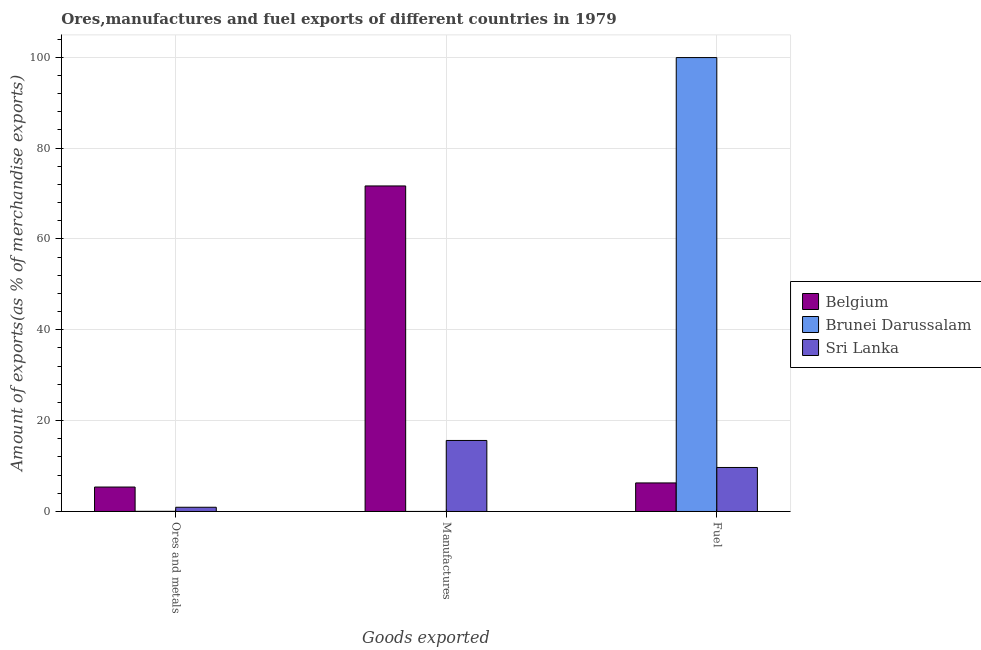How many groups of bars are there?
Offer a terse response. 3. Are the number of bars per tick equal to the number of legend labels?
Provide a succinct answer. Yes. How many bars are there on the 3rd tick from the right?
Your response must be concise. 3. What is the label of the 1st group of bars from the left?
Ensure brevity in your answer.  Ores and metals. What is the percentage of ores and metals exports in Sri Lanka?
Give a very brief answer. 0.93. Across all countries, what is the maximum percentage of fuel exports?
Keep it short and to the point. 99.93. Across all countries, what is the minimum percentage of manufactures exports?
Keep it short and to the point. 0.01. In which country was the percentage of manufactures exports maximum?
Give a very brief answer. Belgium. In which country was the percentage of fuel exports minimum?
Ensure brevity in your answer.  Belgium. What is the total percentage of manufactures exports in the graph?
Ensure brevity in your answer.  87.31. What is the difference between the percentage of ores and metals exports in Sri Lanka and that in Belgium?
Your response must be concise. -4.45. What is the difference between the percentage of ores and metals exports in Brunei Darussalam and the percentage of manufactures exports in Belgium?
Your response must be concise. -71.63. What is the average percentage of fuel exports per country?
Provide a short and direct response. 38.64. What is the difference between the percentage of fuel exports and percentage of ores and metals exports in Brunei Darussalam?
Your response must be concise. 99.9. What is the ratio of the percentage of manufactures exports in Belgium to that in Brunei Darussalam?
Offer a very short reply. 1.02e+04. Is the difference between the percentage of manufactures exports in Brunei Darussalam and Belgium greater than the difference between the percentage of ores and metals exports in Brunei Darussalam and Belgium?
Provide a short and direct response. No. What is the difference between the highest and the second highest percentage of manufactures exports?
Offer a terse response. 56.03. What is the difference between the highest and the lowest percentage of manufactures exports?
Your response must be concise. 71.66. Is the sum of the percentage of fuel exports in Brunei Darussalam and Belgium greater than the maximum percentage of manufactures exports across all countries?
Your answer should be compact. Yes. What does the 2nd bar from the left in Fuel represents?
Your response must be concise. Brunei Darussalam. What does the 2nd bar from the right in Ores and metals represents?
Your answer should be very brief. Brunei Darussalam. What is the difference between two consecutive major ticks on the Y-axis?
Offer a very short reply. 20. Are the values on the major ticks of Y-axis written in scientific E-notation?
Your answer should be very brief. No. Does the graph contain grids?
Keep it short and to the point. Yes. Where does the legend appear in the graph?
Make the answer very short. Center right. How many legend labels are there?
Offer a very short reply. 3. What is the title of the graph?
Offer a terse response. Ores,manufactures and fuel exports of different countries in 1979. Does "Afghanistan" appear as one of the legend labels in the graph?
Provide a short and direct response. No. What is the label or title of the X-axis?
Offer a very short reply. Goods exported. What is the label or title of the Y-axis?
Make the answer very short. Amount of exports(as % of merchandise exports). What is the Amount of exports(as % of merchandise exports) in Belgium in Ores and metals?
Offer a very short reply. 5.38. What is the Amount of exports(as % of merchandise exports) in Brunei Darussalam in Ores and metals?
Give a very brief answer. 0.03. What is the Amount of exports(as % of merchandise exports) in Sri Lanka in Ores and metals?
Your answer should be compact. 0.93. What is the Amount of exports(as % of merchandise exports) in Belgium in Manufactures?
Keep it short and to the point. 71.67. What is the Amount of exports(as % of merchandise exports) in Brunei Darussalam in Manufactures?
Provide a short and direct response. 0.01. What is the Amount of exports(as % of merchandise exports) in Sri Lanka in Manufactures?
Your answer should be compact. 15.64. What is the Amount of exports(as % of merchandise exports) of Belgium in Fuel?
Provide a succinct answer. 6.29. What is the Amount of exports(as % of merchandise exports) in Brunei Darussalam in Fuel?
Your response must be concise. 99.93. What is the Amount of exports(as % of merchandise exports) in Sri Lanka in Fuel?
Provide a short and direct response. 9.69. Across all Goods exported, what is the maximum Amount of exports(as % of merchandise exports) of Belgium?
Ensure brevity in your answer.  71.67. Across all Goods exported, what is the maximum Amount of exports(as % of merchandise exports) of Brunei Darussalam?
Provide a short and direct response. 99.93. Across all Goods exported, what is the maximum Amount of exports(as % of merchandise exports) in Sri Lanka?
Offer a terse response. 15.64. Across all Goods exported, what is the minimum Amount of exports(as % of merchandise exports) of Belgium?
Offer a very short reply. 5.38. Across all Goods exported, what is the minimum Amount of exports(as % of merchandise exports) in Brunei Darussalam?
Provide a short and direct response. 0.01. Across all Goods exported, what is the minimum Amount of exports(as % of merchandise exports) of Sri Lanka?
Your answer should be very brief. 0.93. What is the total Amount of exports(as % of merchandise exports) in Belgium in the graph?
Provide a succinct answer. 83.34. What is the total Amount of exports(as % of merchandise exports) in Brunei Darussalam in the graph?
Provide a short and direct response. 99.97. What is the total Amount of exports(as % of merchandise exports) of Sri Lanka in the graph?
Provide a short and direct response. 26.25. What is the difference between the Amount of exports(as % of merchandise exports) of Belgium in Ores and metals and that in Manufactures?
Your answer should be compact. -66.29. What is the difference between the Amount of exports(as % of merchandise exports) of Brunei Darussalam in Ores and metals and that in Manufactures?
Ensure brevity in your answer.  0.03. What is the difference between the Amount of exports(as % of merchandise exports) of Sri Lanka in Ores and metals and that in Manufactures?
Offer a very short reply. -14.71. What is the difference between the Amount of exports(as % of merchandise exports) in Belgium in Ores and metals and that in Fuel?
Provide a succinct answer. -0.91. What is the difference between the Amount of exports(as % of merchandise exports) in Brunei Darussalam in Ores and metals and that in Fuel?
Your answer should be very brief. -99.9. What is the difference between the Amount of exports(as % of merchandise exports) in Sri Lanka in Ores and metals and that in Fuel?
Your response must be concise. -8.76. What is the difference between the Amount of exports(as % of merchandise exports) in Belgium in Manufactures and that in Fuel?
Ensure brevity in your answer.  65.38. What is the difference between the Amount of exports(as % of merchandise exports) in Brunei Darussalam in Manufactures and that in Fuel?
Your answer should be compact. -99.92. What is the difference between the Amount of exports(as % of merchandise exports) of Sri Lanka in Manufactures and that in Fuel?
Give a very brief answer. 5.95. What is the difference between the Amount of exports(as % of merchandise exports) in Belgium in Ores and metals and the Amount of exports(as % of merchandise exports) in Brunei Darussalam in Manufactures?
Offer a very short reply. 5.37. What is the difference between the Amount of exports(as % of merchandise exports) of Belgium in Ores and metals and the Amount of exports(as % of merchandise exports) of Sri Lanka in Manufactures?
Make the answer very short. -10.26. What is the difference between the Amount of exports(as % of merchandise exports) of Brunei Darussalam in Ores and metals and the Amount of exports(as % of merchandise exports) of Sri Lanka in Manufactures?
Offer a very short reply. -15.6. What is the difference between the Amount of exports(as % of merchandise exports) of Belgium in Ores and metals and the Amount of exports(as % of merchandise exports) of Brunei Darussalam in Fuel?
Provide a succinct answer. -94.55. What is the difference between the Amount of exports(as % of merchandise exports) in Belgium in Ores and metals and the Amount of exports(as % of merchandise exports) in Sri Lanka in Fuel?
Ensure brevity in your answer.  -4.31. What is the difference between the Amount of exports(as % of merchandise exports) in Brunei Darussalam in Ores and metals and the Amount of exports(as % of merchandise exports) in Sri Lanka in Fuel?
Provide a short and direct response. -9.65. What is the difference between the Amount of exports(as % of merchandise exports) of Belgium in Manufactures and the Amount of exports(as % of merchandise exports) of Brunei Darussalam in Fuel?
Ensure brevity in your answer.  -28.26. What is the difference between the Amount of exports(as % of merchandise exports) in Belgium in Manufactures and the Amount of exports(as % of merchandise exports) in Sri Lanka in Fuel?
Give a very brief answer. 61.98. What is the difference between the Amount of exports(as % of merchandise exports) in Brunei Darussalam in Manufactures and the Amount of exports(as % of merchandise exports) in Sri Lanka in Fuel?
Provide a short and direct response. -9.68. What is the average Amount of exports(as % of merchandise exports) in Belgium per Goods exported?
Your response must be concise. 27.78. What is the average Amount of exports(as % of merchandise exports) in Brunei Darussalam per Goods exported?
Provide a succinct answer. 33.32. What is the average Amount of exports(as % of merchandise exports) of Sri Lanka per Goods exported?
Give a very brief answer. 8.75. What is the difference between the Amount of exports(as % of merchandise exports) of Belgium and Amount of exports(as % of merchandise exports) of Brunei Darussalam in Ores and metals?
Your answer should be compact. 5.34. What is the difference between the Amount of exports(as % of merchandise exports) in Belgium and Amount of exports(as % of merchandise exports) in Sri Lanka in Ores and metals?
Provide a short and direct response. 4.45. What is the difference between the Amount of exports(as % of merchandise exports) of Brunei Darussalam and Amount of exports(as % of merchandise exports) of Sri Lanka in Ores and metals?
Your answer should be compact. -0.89. What is the difference between the Amount of exports(as % of merchandise exports) in Belgium and Amount of exports(as % of merchandise exports) in Brunei Darussalam in Manufactures?
Provide a succinct answer. 71.66. What is the difference between the Amount of exports(as % of merchandise exports) in Belgium and Amount of exports(as % of merchandise exports) in Sri Lanka in Manufactures?
Keep it short and to the point. 56.03. What is the difference between the Amount of exports(as % of merchandise exports) of Brunei Darussalam and Amount of exports(as % of merchandise exports) of Sri Lanka in Manufactures?
Make the answer very short. -15.63. What is the difference between the Amount of exports(as % of merchandise exports) in Belgium and Amount of exports(as % of merchandise exports) in Brunei Darussalam in Fuel?
Your answer should be compact. -93.64. What is the difference between the Amount of exports(as % of merchandise exports) of Belgium and Amount of exports(as % of merchandise exports) of Sri Lanka in Fuel?
Offer a very short reply. -3.4. What is the difference between the Amount of exports(as % of merchandise exports) in Brunei Darussalam and Amount of exports(as % of merchandise exports) in Sri Lanka in Fuel?
Provide a succinct answer. 90.24. What is the ratio of the Amount of exports(as % of merchandise exports) in Belgium in Ores and metals to that in Manufactures?
Make the answer very short. 0.08. What is the ratio of the Amount of exports(as % of merchandise exports) in Brunei Darussalam in Ores and metals to that in Manufactures?
Your answer should be compact. 4.98. What is the ratio of the Amount of exports(as % of merchandise exports) in Sri Lanka in Ores and metals to that in Manufactures?
Offer a very short reply. 0.06. What is the ratio of the Amount of exports(as % of merchandise exports) in Belgium in Ores and metals to that in Fuel?
Your answer should be compact. 0.86. What is the ratio of the Amount of exports(as % of merchandise exports) of Brunei Darussalam in Ores and metals to that in Fuel?
Make the answer very short. 0. What is the ratio of the Amount of exports(as % of merchandise exports) in Sri Lanka in Ores and metals to that in Fuel?
Your answer should be very brief. 0.1. What is the ratio of the Amount of exports(as % of merchandise exports) of Belgium in Manufactures to that in Fuel?
Give a very brief answer. 11.4. What is the ratio of the Amount of exports(as % of merchandise exports) in Brunei Darussalam in Manufactures to that in Fuel?
Give a very brief answer. 0. What is the ratio of the Amount of exports(as % of merchandise exports) of Sri Lanka in Manufactures to that in Fuel?
Give a very brief answer. 1.61. What is the difference between the highest and the second highest Amount of exports(as % of merchandise exports) in Belgium?
Your answer should be compact. 65.38. What is the difference between the highest and the second highest Amount of exports(as % of merchandise exports) in Brunei Darussalam?
Ensure brevity in your answer.  99.9. What is the difference between the highest and the second highest Amount of exports(as % of merchandise exports) in Sri Lanka?
Ensure brevity in your answer.  5.95. What is the difference between the highest and the lowest Amount of exports(as % of merchandise exports) in Belgium?
Offer a terse response. 66.29. What is the difference between the highest and the lowest Amount of exports(as % of merchandise exports) of Brunei Darussalam?
Your response must be concise. 99.92. What is the difference between the highest and the lowest Amount of exports(as % of merchandise exports) in Sri Lanka?
Give a very brief answer. 14.71. 